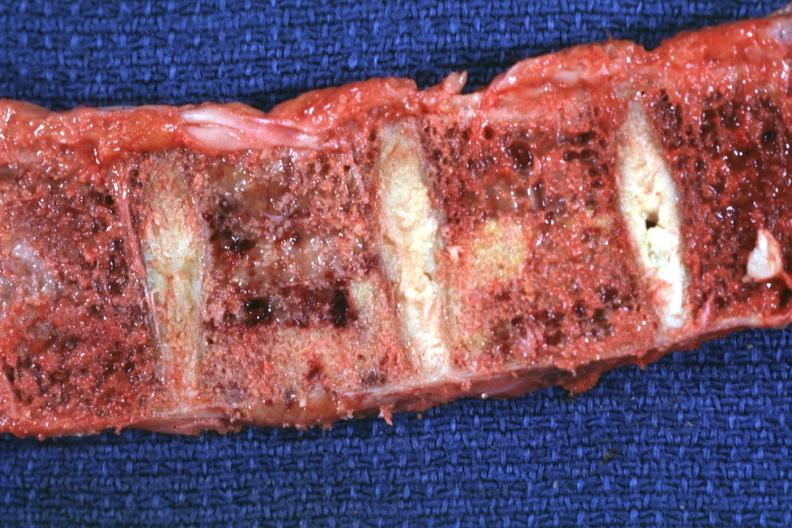what is present?
Answer the question using a single word or phrase. Joints 